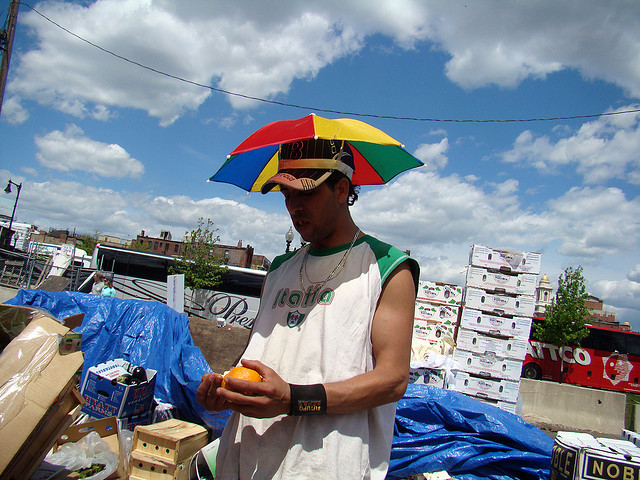Identify and read out the text in this image. NOB ATTCO 8 